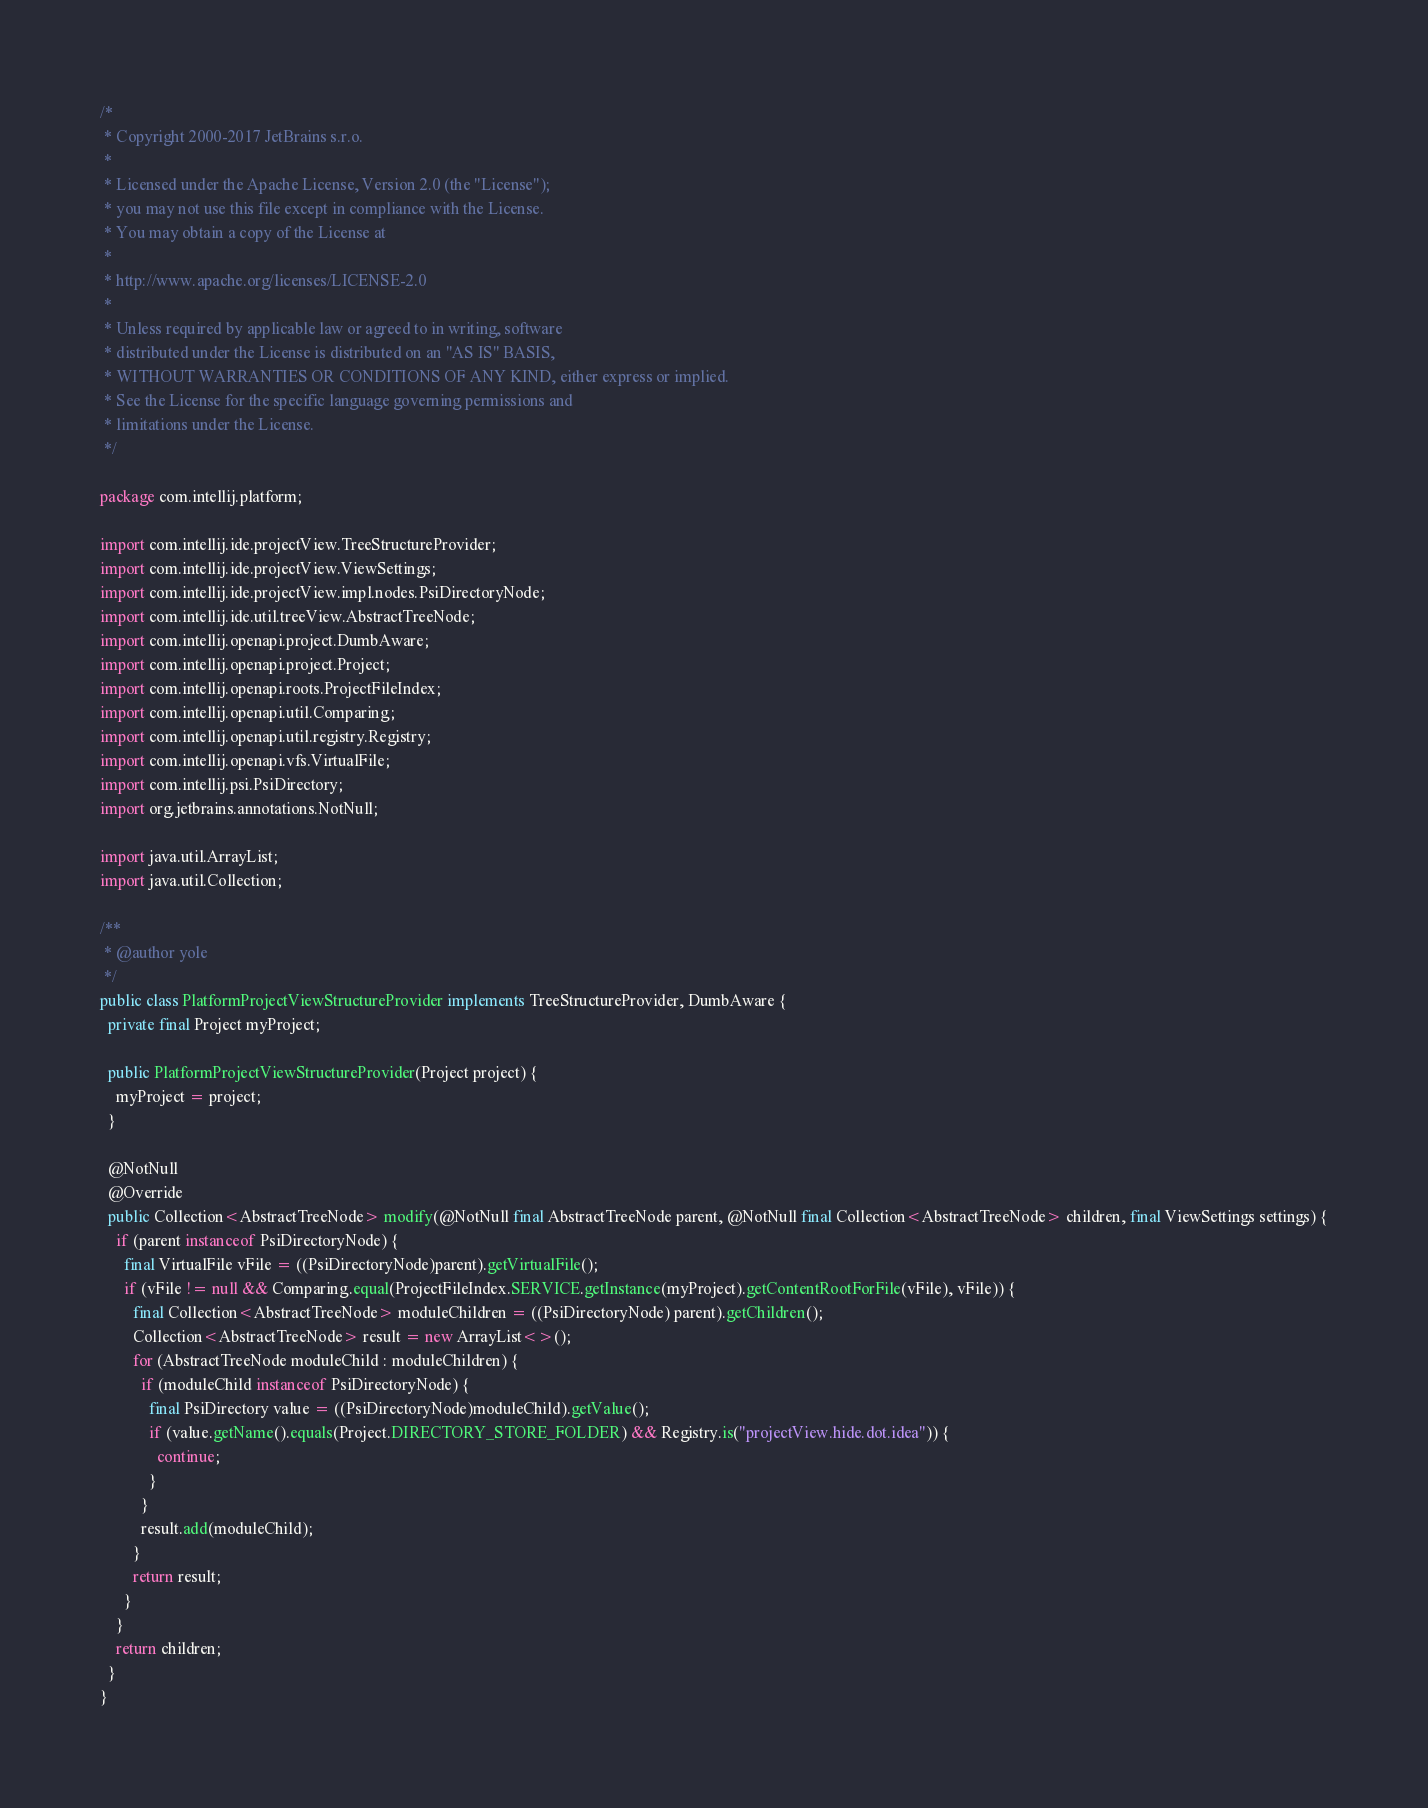Convert code to text. <code><loc_0><loc_0><loc_500><loc_500><_Java_>/*
 * Copyright 2000-2017 JetBrains s.r.o.
 *
 * Licensed under the Apache License, Version 2.0 (the "License");
 * you may not use this file except in compliance with the License.
 * You may obtain a copy of the License at
 *
 * http://www.apache.org/licenses/LICENSE-2.0
 *
 * Unless required by applicable law or agreed to in writing, software
 * distributed under the License is distributed on an "AS IS" BASIS,
 * WITHOUT WARRANTIES OR CONDITIONS OF ANY KIND, either express or implied.
 * See the License for the specific language governing permissions and
 * limitations under the License.
 */

package com.intellij.platform;

import com.intellij.ide.projectView.TreeStructureProvider;
import com.intellij.ide.projectView.ViewSettings;
import com.intellij.ide.projectView.impl.nodes.PsiDirectoryNode;
import com.intellij.ide.util.treeView.AbstractTreeNode;
import com.intellij.openapi.project.DumbAware;
import com.intellij.openapi.project.Project;
import com.intellij.openapi.roots.ProjectFileIndex;
import com.intellij.openapi.util.Comparing;
import com.intellij.openapi.util.registry.Registry;
import com.intellij.openapi.vfs.VirtualFile;
import com.intellij.psi.PsiDirectory;
import org.jetbrains.annotations.NotNull;

import java.util.ArrayList;
import java.util.Collection;

/**
 * @author yole
 */
public class PlatformProjectViewStructureProvider implements TreeStructureProvider, DumbAware {
  private final Project myProject;

  public PlatformProjectViewStructureProvider(Project project) {
    myProject = project;
  }

  @NotNull
  @Override
  public Collection<AbstractTreeNode> modify(@NotNull final AbstractTreeNode parent, @NotNull final Collection<AbstractTreeNode> children, final ViewSettings settings) {
    if (parent instanceof PsiDirectoryNode) {
      final VirtualFile vFile = ((PsiDirectoryNode)parent).getVirtualFile();
      if (vFile != null && Comparing.equal(ProjectFileIndex.SERVICE.getInstance(myProject).getContentRootForFile(vFile), vFile)) {
        final Collection<AbstractTreeNode> moduleChildren = ((PsiDirectoryNode) parent).getChildren();
        Collection<AbstractTreeNode> result = new ArrayList<>();
        for (AbstractTreeNode moduleChild : moduleChildren) {
          if (moduleChild instanceof PsiDirectoryNode) {
            final PsiDirectory value = ((PsiDirectoryNode)moduleChild).getValue();
            if (value.getName().equals(Project.DIRECTORY_STORE_FOLDER) && Registry.is("projectView.hide.dot.idea")) {
              continue;
            }
          }
          result.add(moduleChild);
        }
        return result;
      }
    }
    return children;
  }
}
</code> 